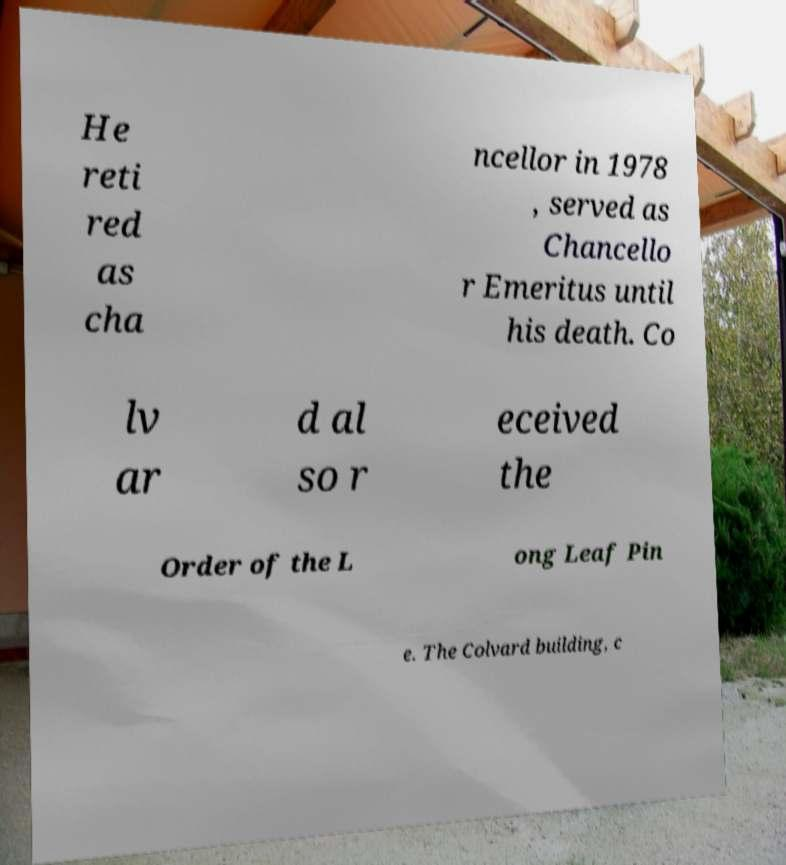Could you extract and type out the text from this image? He reti red as cha ncellor in 1978 , served as Chancello r Emeritus until his death. Co lv ar d al so r eceived the Order of the L ong Leaf Pin e. The Colvard building, c 